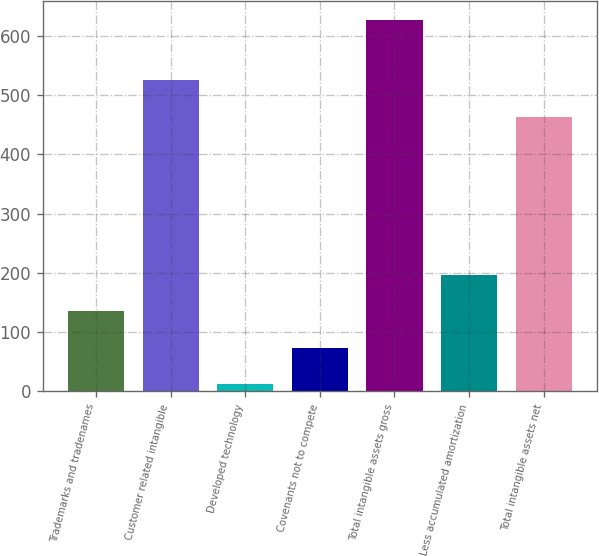Convert chart to OTSL. <chart><loc_0><loc_0><loc_500><loc_500><bar_chart><fcel>Trademarks and tradenames<fcel>Customer related intangible<fcel>Developed technology<fcel>Covenants not to compete<fcel>Total intangible assets gross<fcel>Less accumulated amortization<fcel>Total intangible assets net<nl><fcel>135<fcel>526<fcel>12<fcel>73.5<fcel>627<fcel>196.5<fcel>463<nl></chart> 